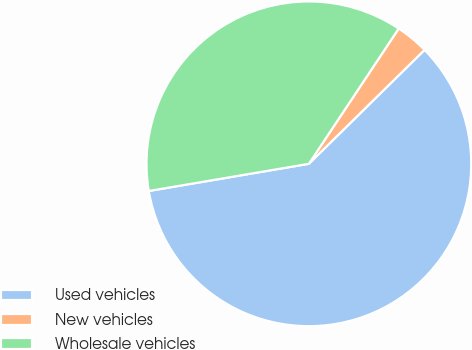Convert chart to OTSL. <chart><loc_0><loc_0><loc_500><loc_500><pie_chart><fcel>Used vehicles<fcel>New vehicles<fcel>Wholesale vehicles<nl><fcel>59.7%<fcel>3.29%<fcel>37.01%<nl></chart> 